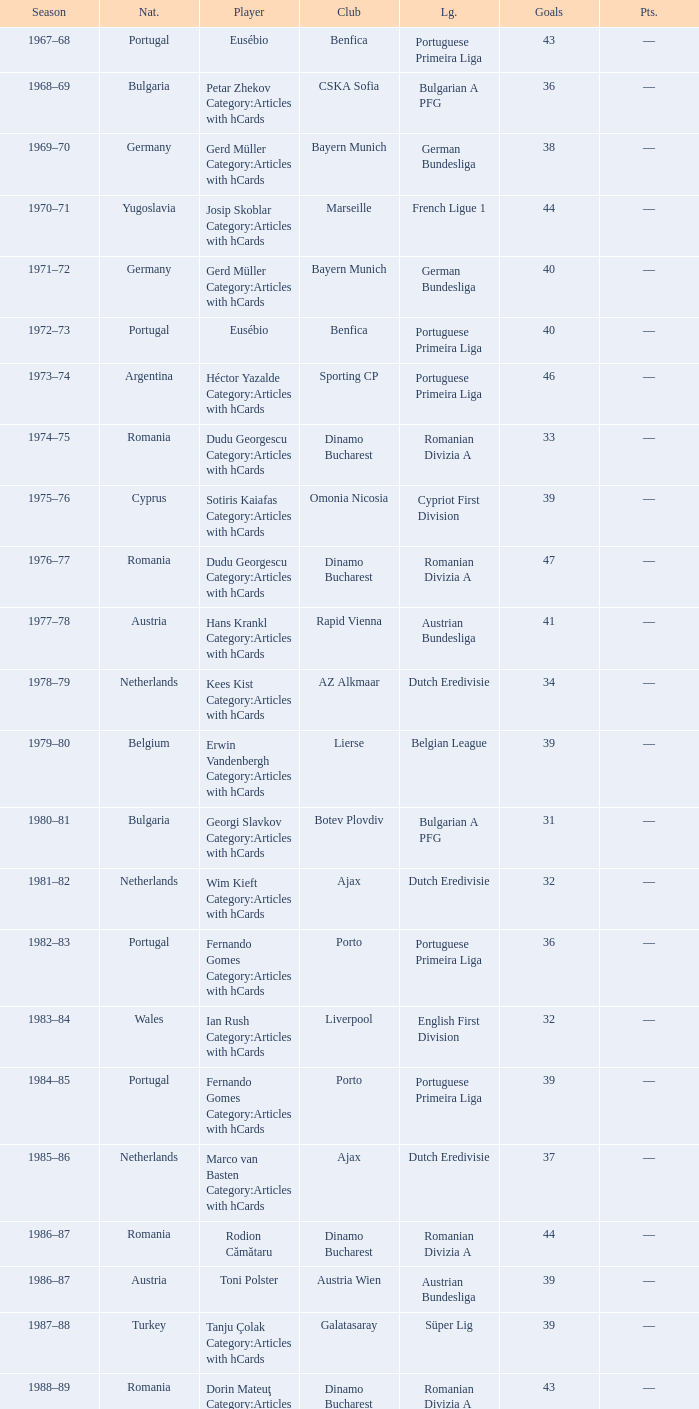Which player was in the Omonia Nicosia club? Sotiris Kaiafas Category:Articles with hCards. 